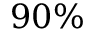Convert formula to latex. <formula><loc_0><loc_0><loc_500><loc_500>9 0 \%</formula> 